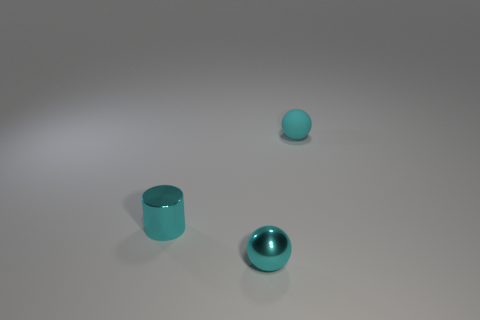Subtract all brown spheres. Subtract all cyan cubes. How many spheres are left? 2 Subtract all green blocks. How many red balls are left? 0 Add 2 greens. How many tiny objects exist? 0 Subtract all small balls. Subtract all tiny cyan cylinders. How many objects are left? 0 Add 2 spheres. How many spheres are left? 4 Add 3 small rubber spheres. How many small rubber spheres exist? 4 Add 3 small objects. How many objects exist? 6 Subtract 0 red cylinders. How many objects are left? 3 Subtract all cylinders. How many objects are left? 2 Subtract 1 cylinders. How many cylinders are left? 0 